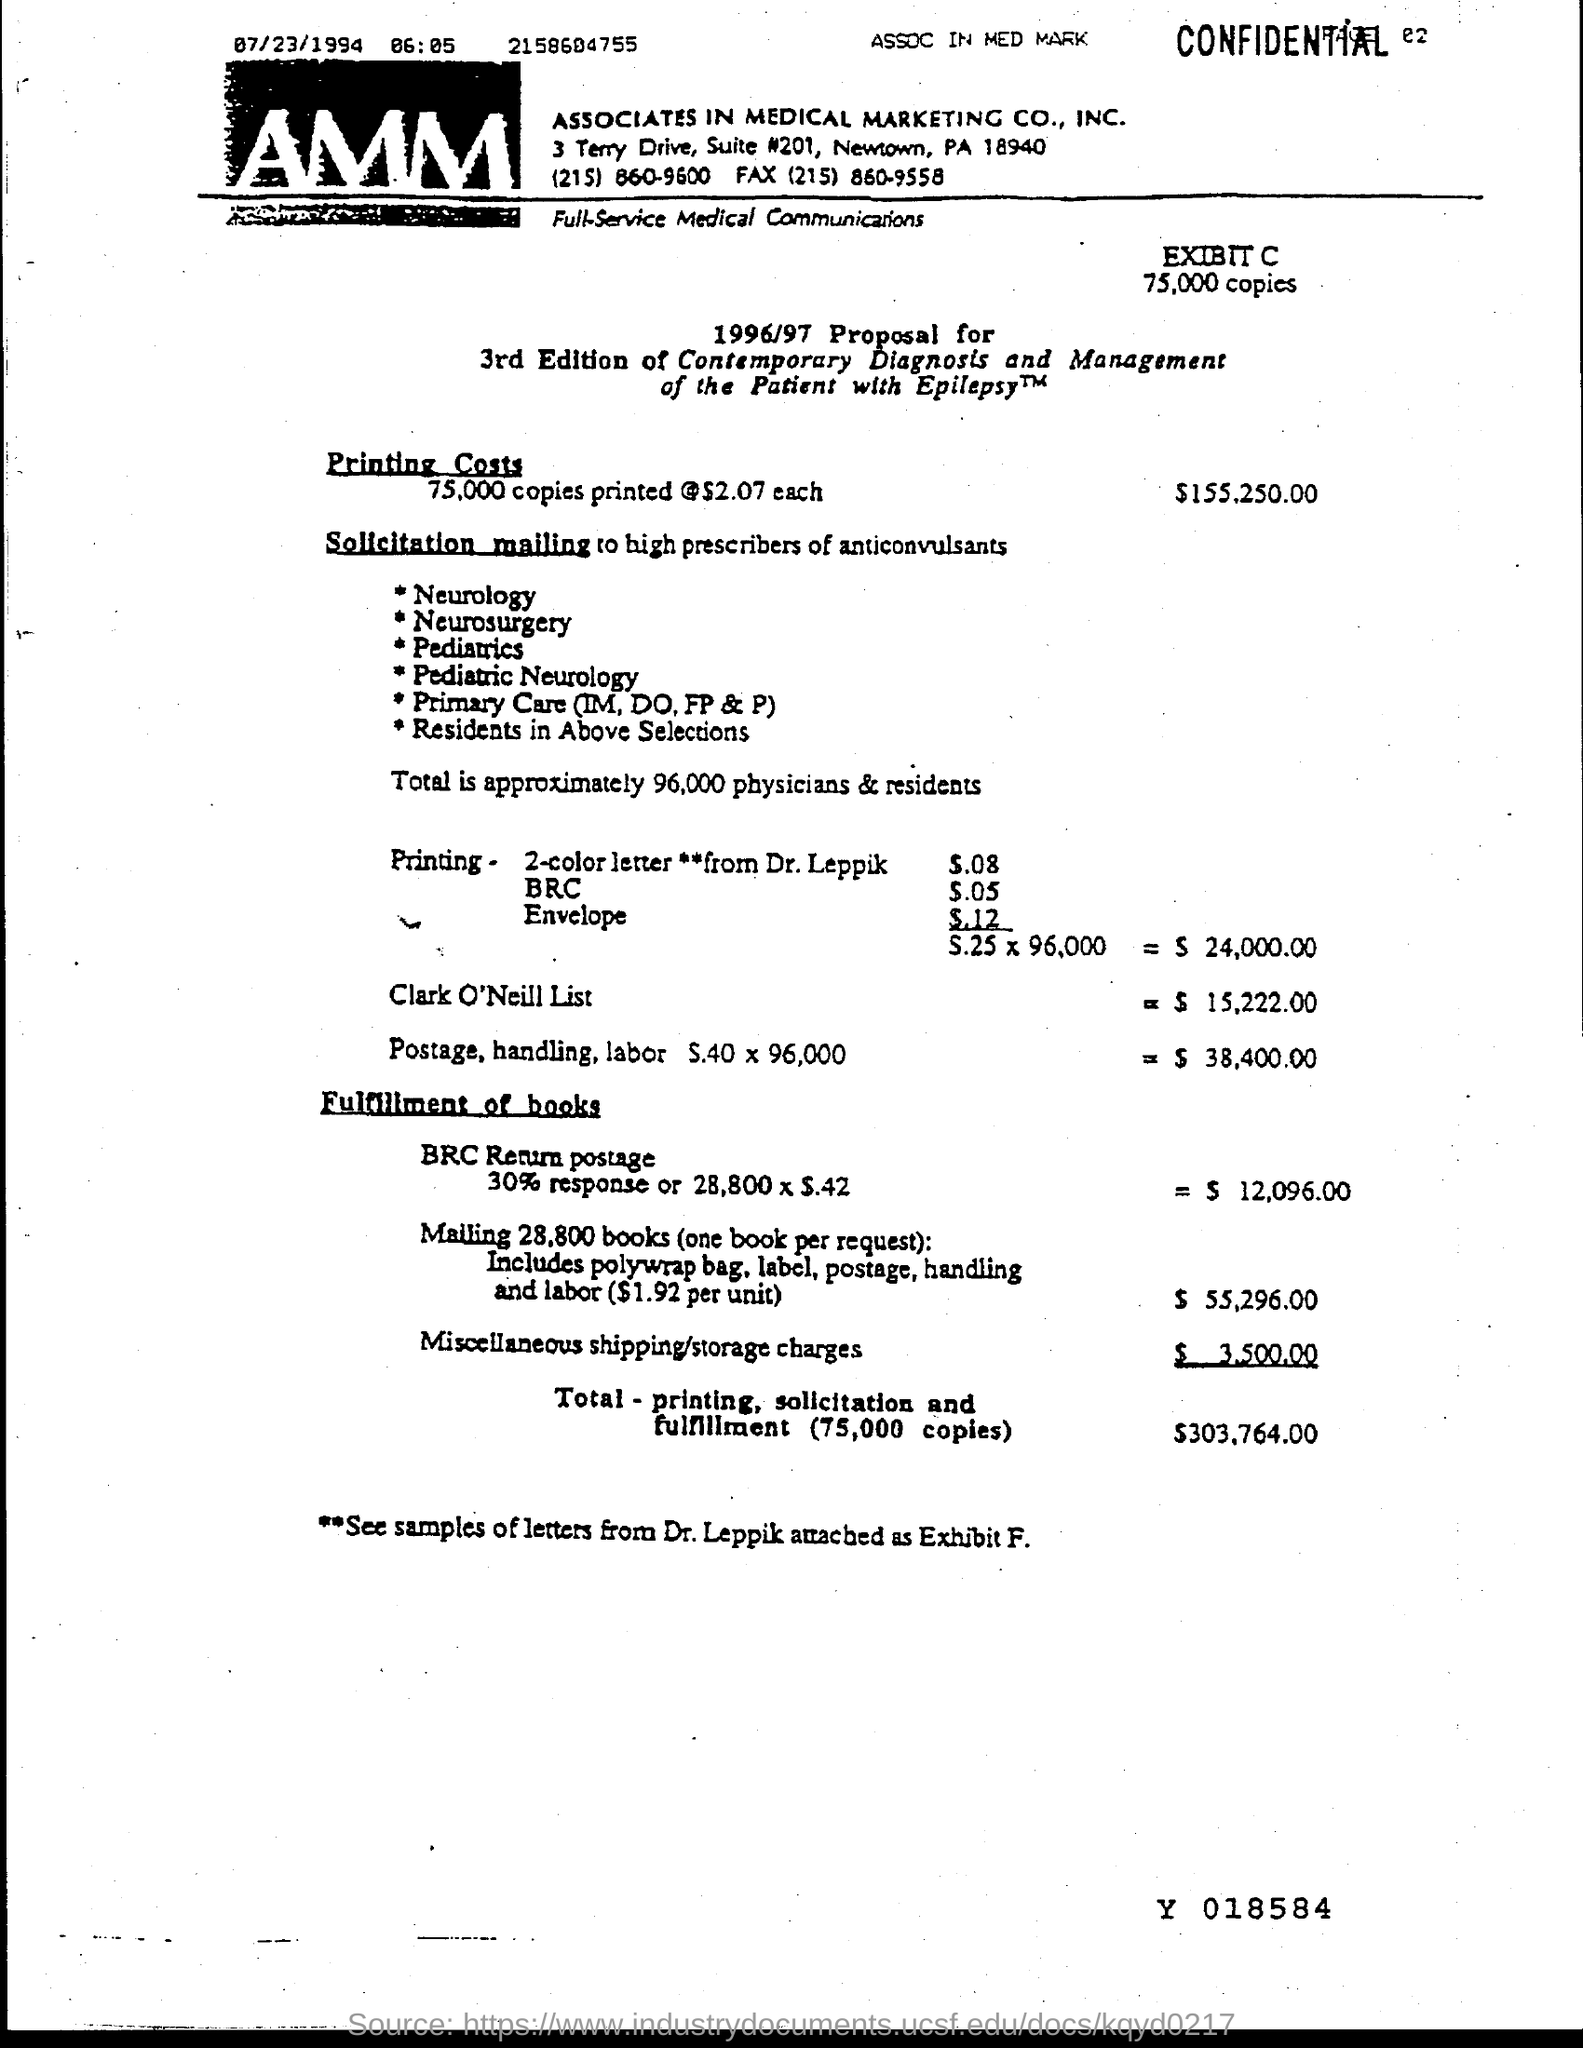Specify some key components in this picture. Associates in Medical Marketing Co., Inc. is located in Newtown, a city in the United States. The total amount for printing, solicitation, and fulfillment of 75,000 copies is $303,764.00. 